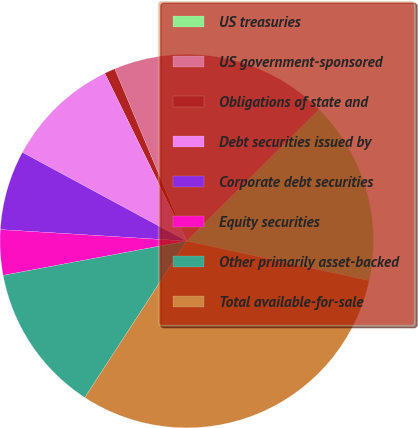Convert chart to OTSL. <chart><loc_0><loc_0><loc_500><loc_500><pie_chart><fcel>US treasuries<fcel>US government-sponsored<fcel>Obligations of state and<fcel>Debt securities issued by<fcel>Corporate debt securities<fcel>Equity securities<fcel>Other primarily asset-backed<fcel>Total available-for-sale<nl><fcel>15.86%<fcel>18.84%<fcel>0.93%<fcel>9.89%<fcel>6.9%<fcel>3.92%<fcel>12.87%<fcel>30.78%<nl></chart> 